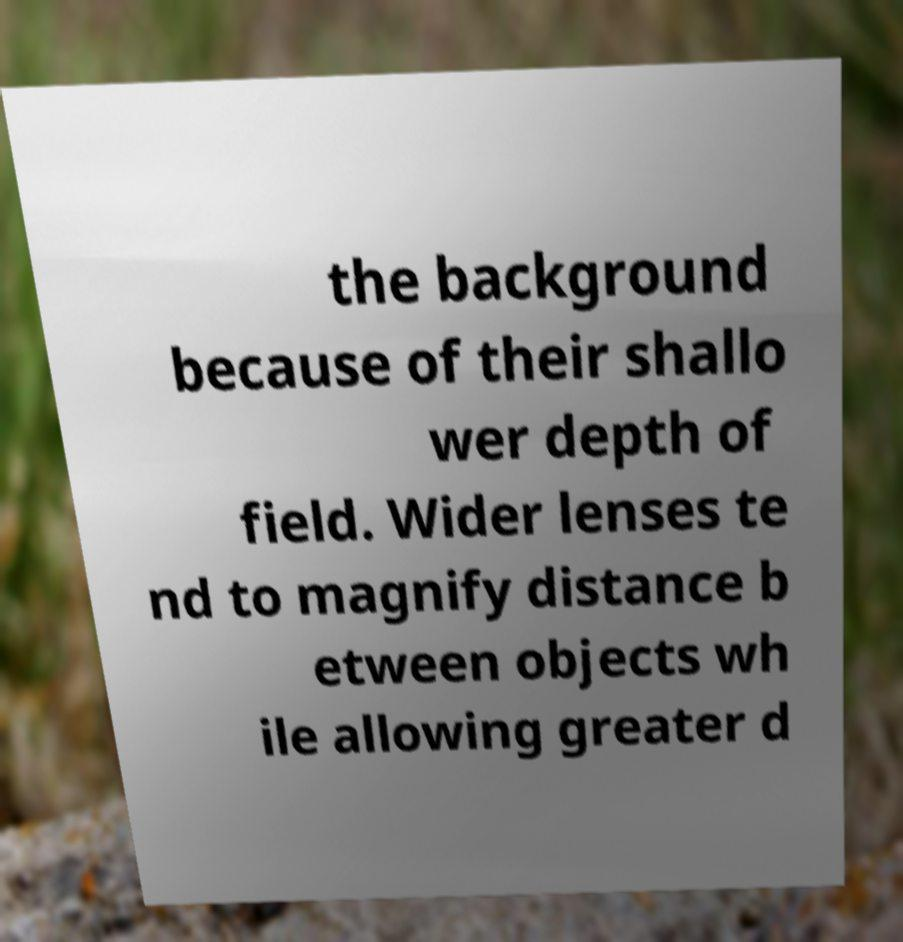Please read and relay the text visible in this image. What does it say? the background because of their shallo wer depth of field. Wider lenses te nd to magnify distance b etween objects wh ile allowing greater d 